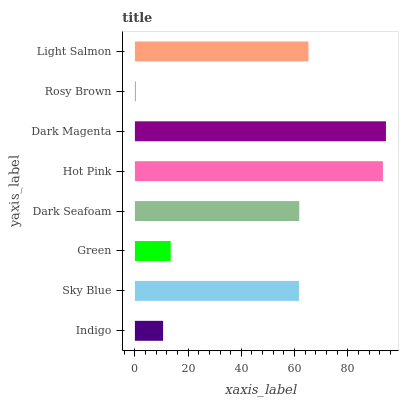Is Rosy Brown the minimum?
Answer yes or no. Yes. Is Dark Magenta the maximum?
Answer yes or no. Yes. Is Sky Blue the minimum?
Answer yes or no. No. Is Sky Blue the maximum?
Answer yes or no. No. Is Sky Blue greater than Indigo?
Answer yes or no. Yes. Is Indigo less than Sky Blue?
Answer yes or no. Yes. Is Indigo greater than Sky Blue?
Answer yes or no. No. Is Sky Blue less than Indigo?
Answer yes or no. No. Is Dark Seafoam the high median?
Answer yes or no. Yes. Is Sky Blue the low median?
Answer yes or no. Yes. Is Indigo the high median?
Answer yes or no. No. Is Light Salmon the low median?
Answer yes or no. No. 